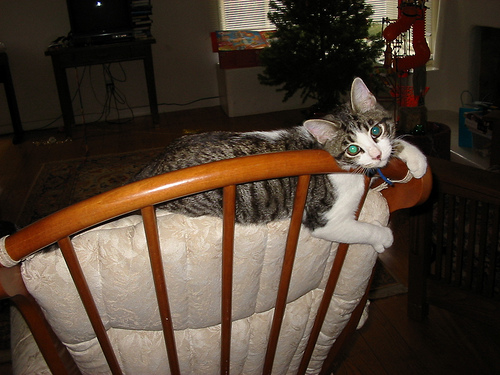<image>What style of chair is the cat resting on? It is unclear what style of chair the cat is resting on. It could be a papasan chair, a lounge chair, a round back chair, a rocking chair, or a shaker chair. What style of chair is the cat resting on? I don't know what style of chair the cat is resting on. It can be seen as a papasan chair or a lounge chair. 